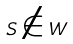Convert formula to latex. <formula><loc_0><loc_0><loc_500><loc_500>S \notin W</formula> 